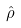Convert formula to latex. <formula><loc_0><loc_0><loc_500><loc_500>\hat { \rho }</formula> 